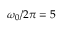<formula> <loc_0><loc_0><loc_500><loc_500>\omega _ { 0 } / 2 \pi = 5</formula> 